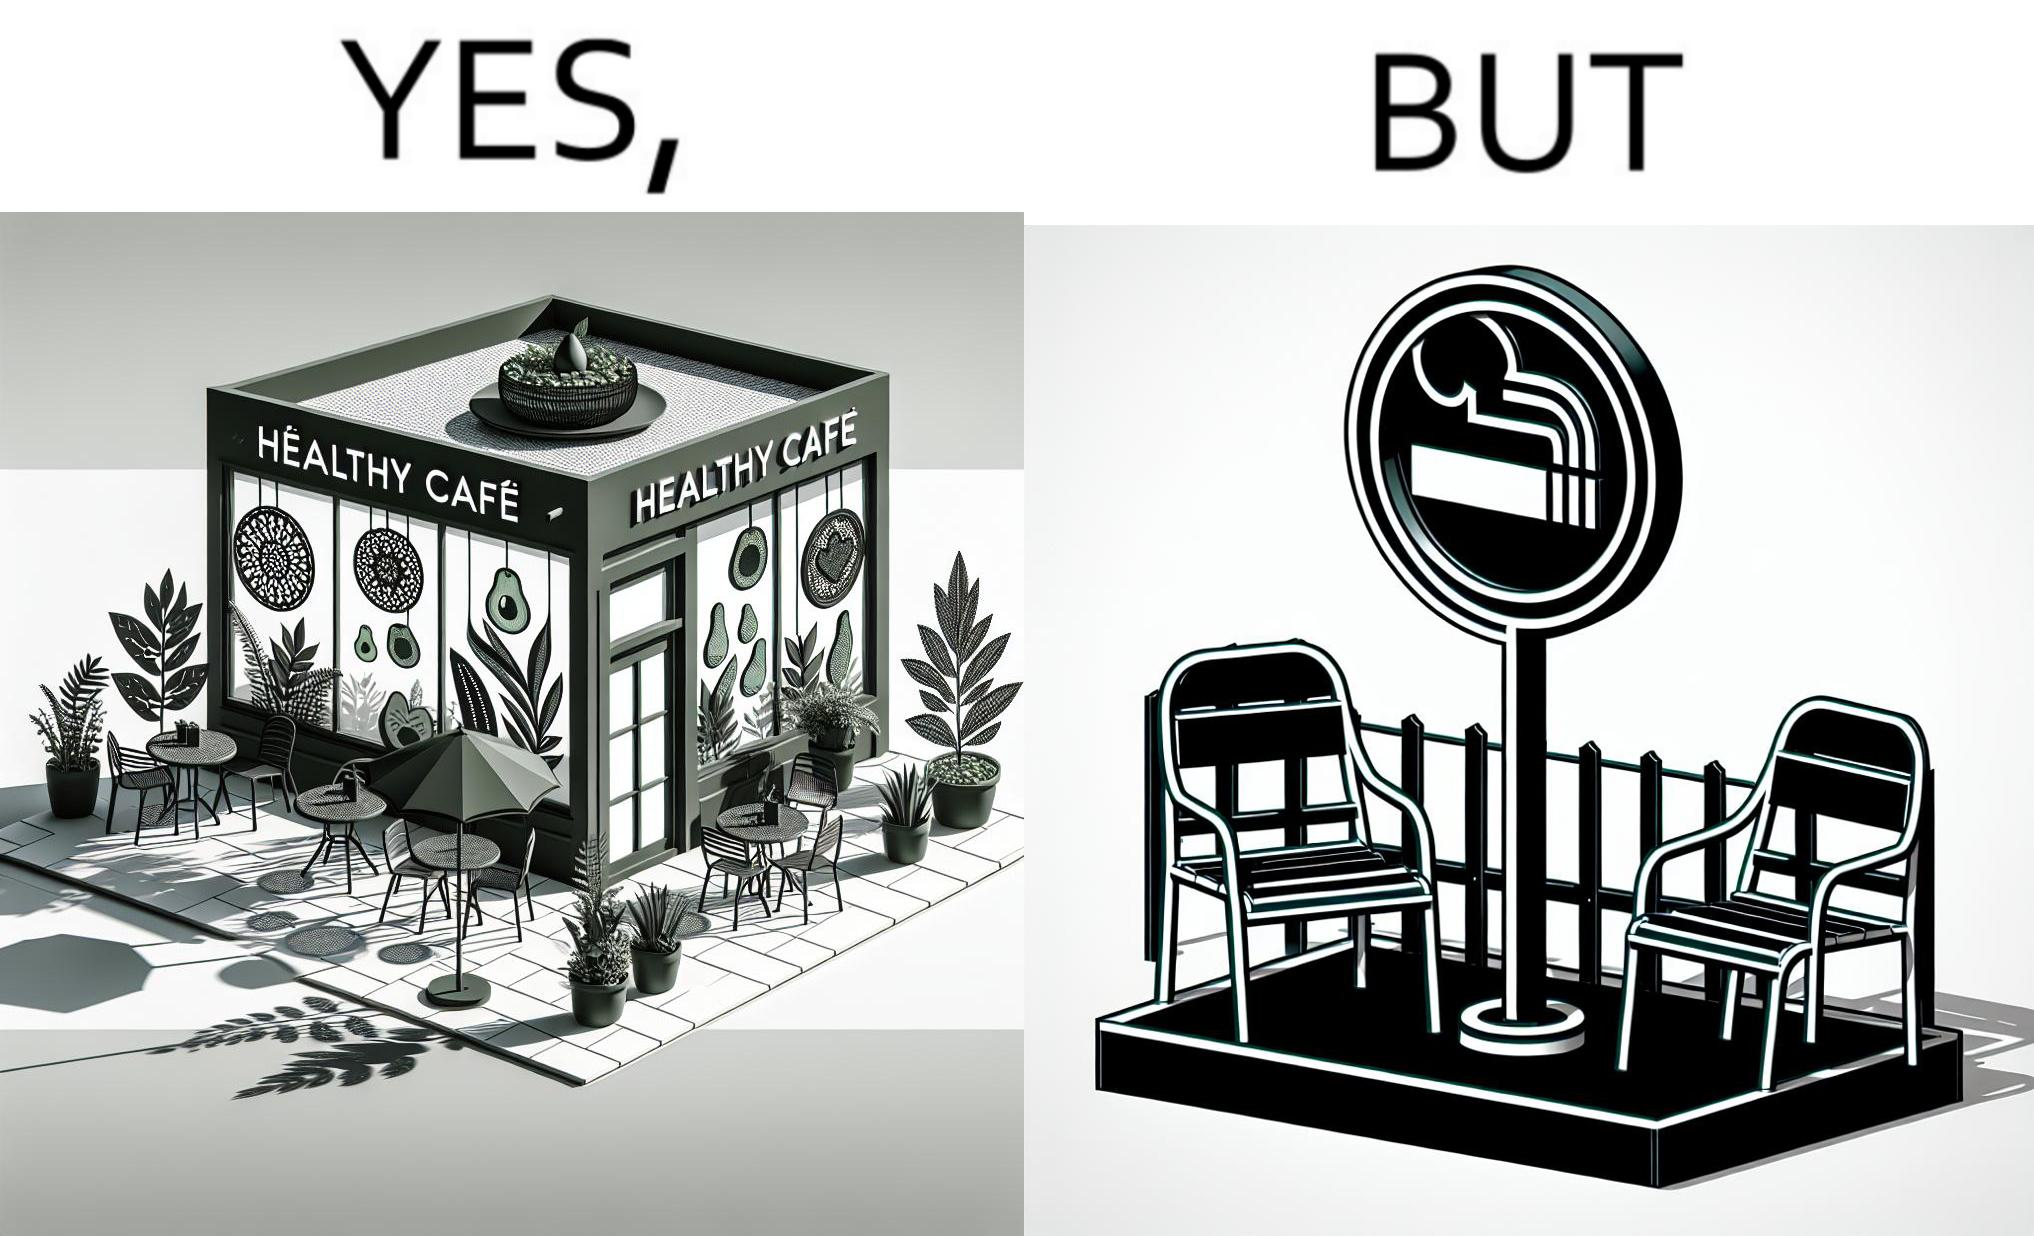What do you see in each half of this image? In the left part of the image: An eatery with the name "Healthy Cafe". It has a green aesthetic with paintings of leaves, avocados, etc on their windows. They have an outdoor seating area with 4 green patio chairs around a circular table. There is a small sign on a stand near the table with a green circular symbol and some text that is too small to read. In the right part of the image: Green patio chairs. A sign on a stand that has a green circular symbol encircling a cigarette symbol, and some text that says "SMOKING AREA". 